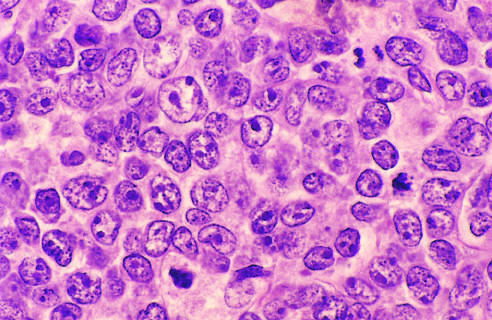do neutrophils have large nuclei with open chromatin and prominent nucleoli?
Answer the question using a single word or phrase. No 